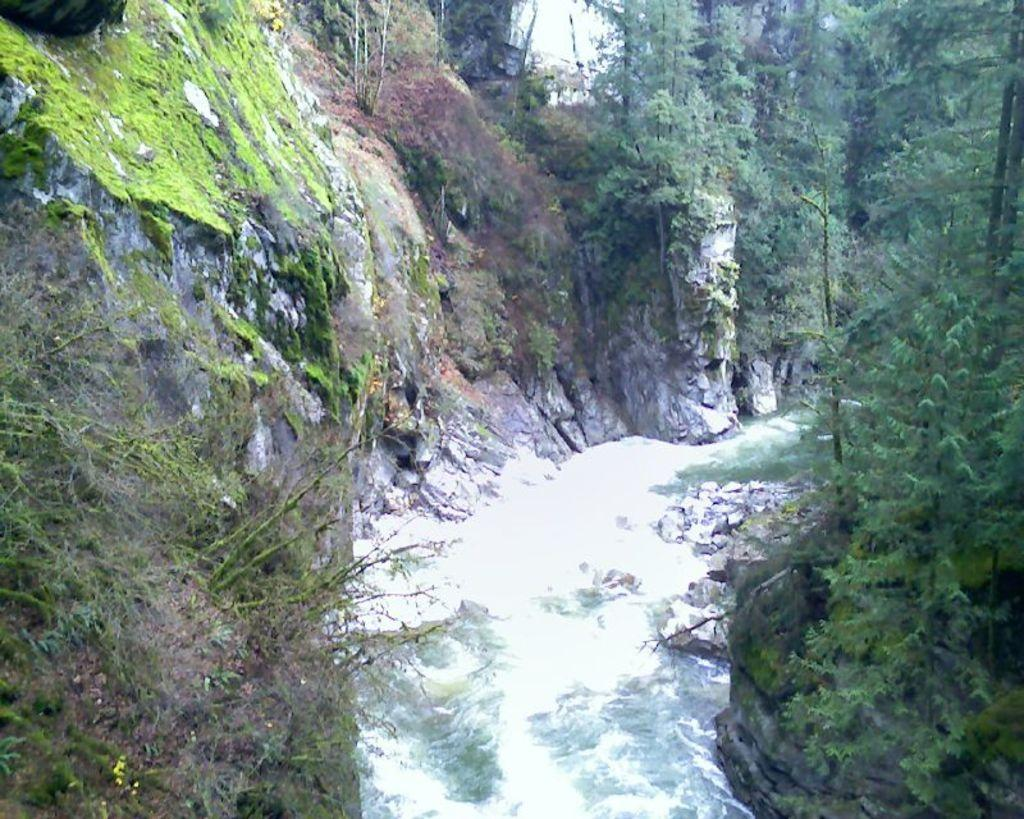What is happening in the image? Water is flowing in the image. What type of natural features can be seen in the image? Rocks and trees are present in the image. Can you describe the vegetation in the image? There are trees in the image. What is unique about the grass in the image? Grass is visible on a rock in the top left area of the image. How does the hen contribute to the driving experience in the image? There is no hen or driving present in the image. 